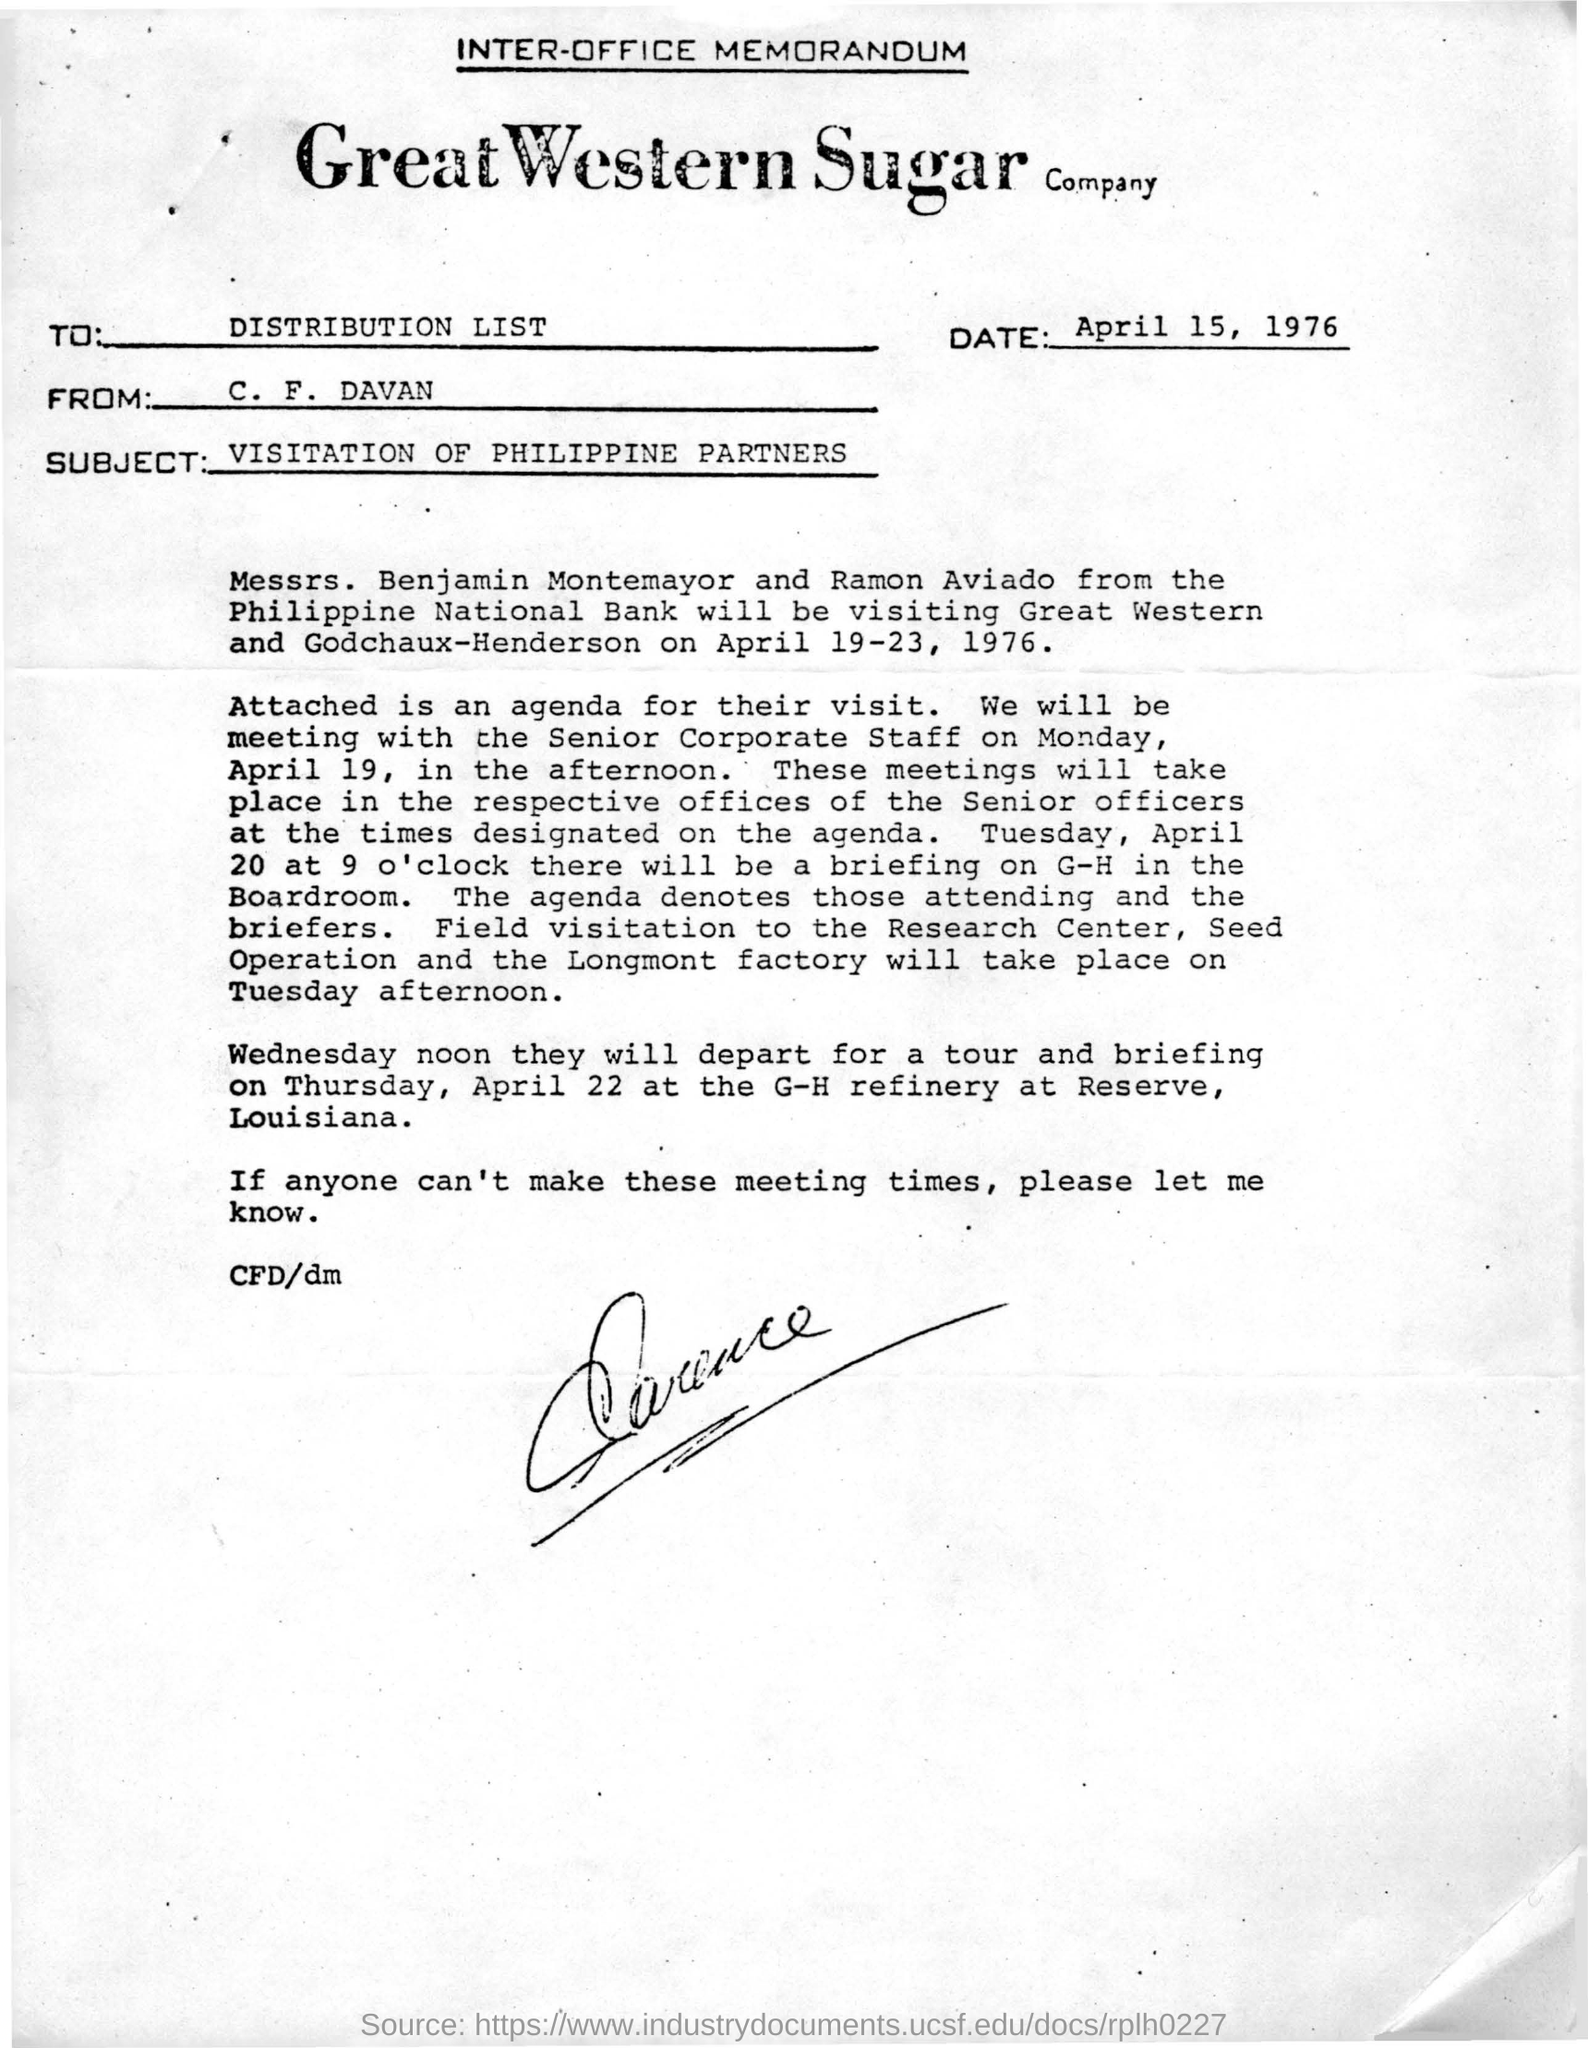Give some essential details in this illustration. The sender of this memorandum is C. F. Davan. The memorandum is dated April 15, 1976. On April 19-23, 1976, representatives from the Philippine National Bank, Messrs. Benjamin Montemayor and Ramon Aviado, will be visiting Great Western and Godchaux-Henderson. The individuals known as Messrs. Benjamin montemayor and Ramon Aviado are from the Philippines, and they are employees of the Philippine National Bank. 